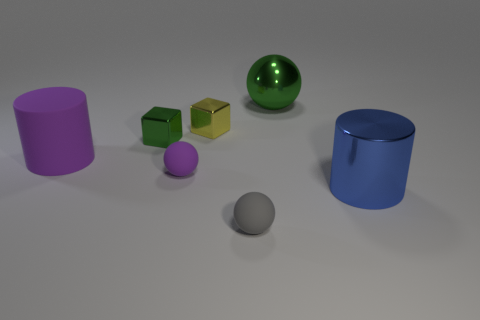What is the material of the tiny sphere that is on the right side of the small purple matte ball that is in front of the large green ball?
Your answer should be very brief. Rubber. The green sphere has what size?
Offer a terse response. Large. How many matte things are the same size as the blue cylinder?
Offer a terse response. 1. How many purple rubber things have the same shape as the tiny gray matte thing?
Make the answer very short. 1. Are there an equal number of small matte spheres that are in front of the purple ball and tiny balls?
Your response must be concise. No. Is there anything else that has the same size as the blue shiny object?
Make the answer very short. Yes. The purple matte thing that is the same size as the gray matte sphere is what shape?
Your response must be concise. Sphere. Are there any small brown matte objects of the same shape as the big blue object?
Offer a very short reply. No. There is a green thing that is left of the sphere that is behind the big rubber object; are there any small cubes that are to the left of it?
Give a very brief answer. No. Are there more large cylinders on the left side of the large blue cylinder than yellow shiny blocks on the right side of the tiny gray object?
Make the answer very short. Yes. 